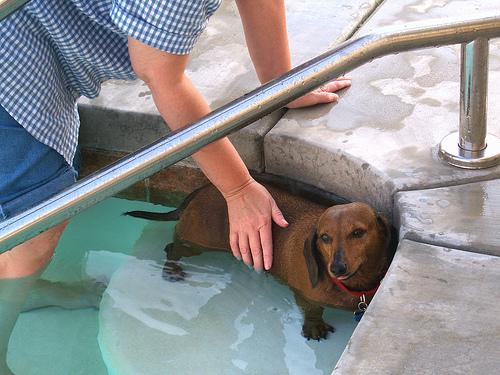How many objects related to water can you recognize in the picture? Five objects: pool, bluish-green water, wet concrete pavement, wet silver railing, and bare feet in the pool. What is the overall quality of the image with respect to its objects and composition? The image is highly detailed with various objects, such as the dog, woman, clothing items, and pool structures, making it a rich and engaging composition. Identify and describe the object used for safety in the pool. A silver handrail leading to the water, used for support and safety when entering or exiting the pool. What type of animal is in the image, and what distinguishing feature does it have? A dog with long floppy ears and tongue sticking out, wearing a red collar with a tag. Perform a sentiment analysis of the image by describing the main subject and the general emotion conveyed. A happy and adorable dog is in a pool with a woman petting it, conveying a joyful and relaxing atmosphere. Can you tell me about the woman in this picture and what she's doing? The woman is wearing a blue and white checkered shirt and petting the dog, she has her feet in the water. Analyze two objects in the image that demonstrate how the objects are interacting with each other. The woman's hand is petting the dog, and the dog's legs are immersed in the water, indicating interaction between the woman, dog, and pool. Describe a unique feature related to the dog's appearance that makes it look appealing or cute. The cute little doggy face is sticking its tongue out, adding to its adorable and endearing appearance. How many individuals are in the image, and what are they wearing? There are two individuals: a woman wearing a blue and white checkered shirt, and a person wearing blue shorts rolled into jeans. Identify the type of dog in the image based on its physical appearance. A short brown weiner dog with brown eyes, black nails, and a wet tail. 